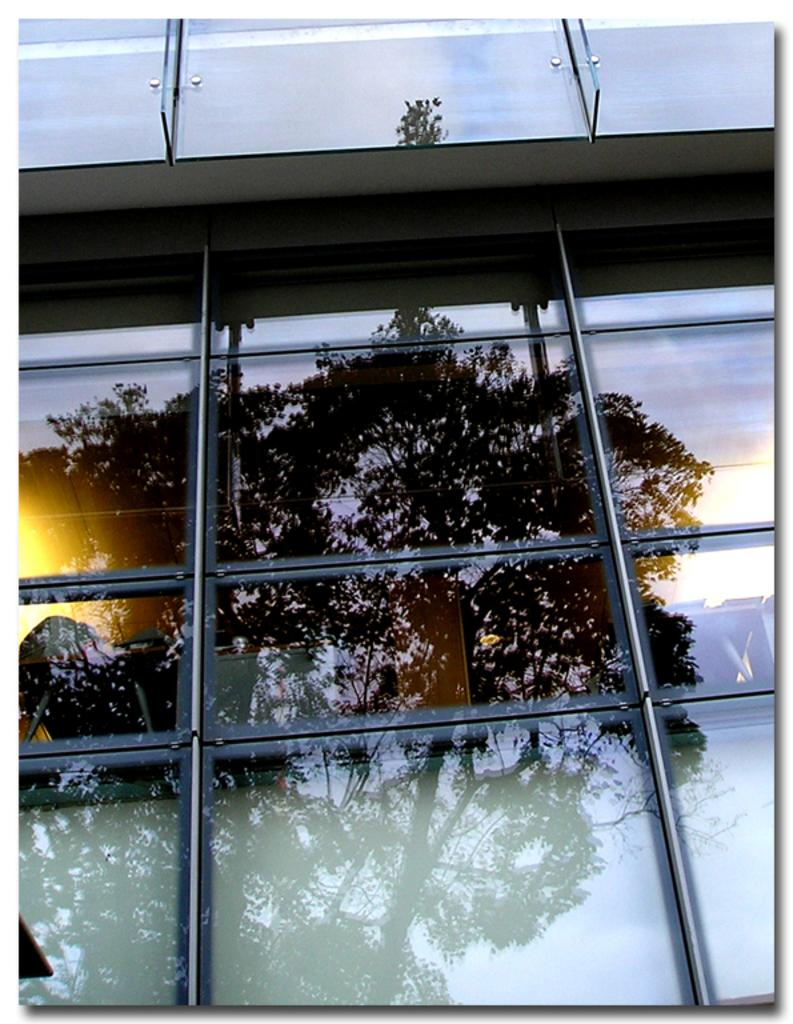What type of structure is present in the image? There is a building in the image. What feature can be observed on the building? The building has glass doors. What can be seen through the glass doors? A shadow of a tree is visible through the glass doors. How many people are in the crowd outside the building in the image? There is no crowd present in the image; it only shows a building with glass doors and a shadow of a tree. 